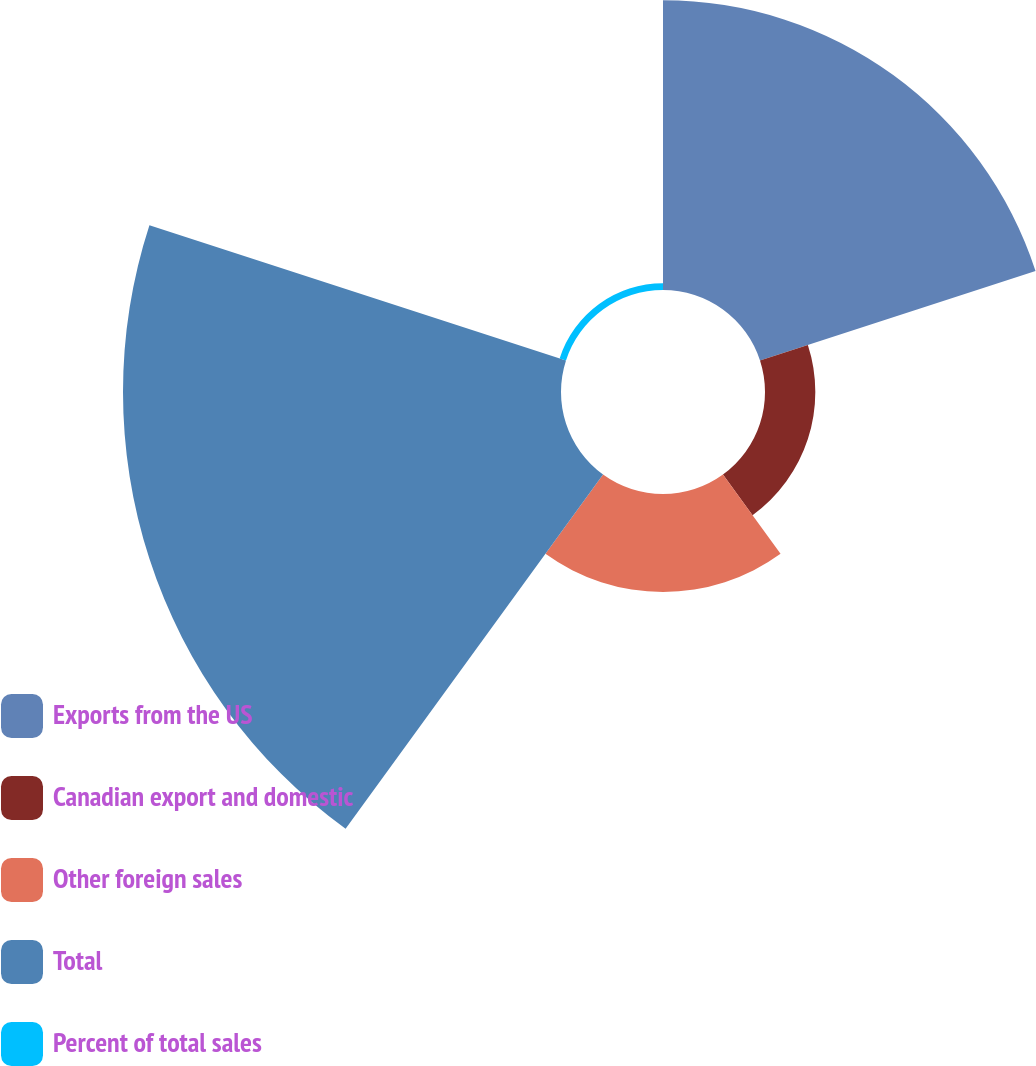<chart> <loc_0><loc_0><loc_500><loc_500><pie_chart><fcel>Exports from the US<fcel>Canadian export and domestic<fcel>Other foreign sales<fcel>Total<fcel>Percent of total sales<nl><fcel>32.82%<fcel>5.7%<fcel>11.1%<fcel>49.62%<fcel>0.76%<nl></chart> 